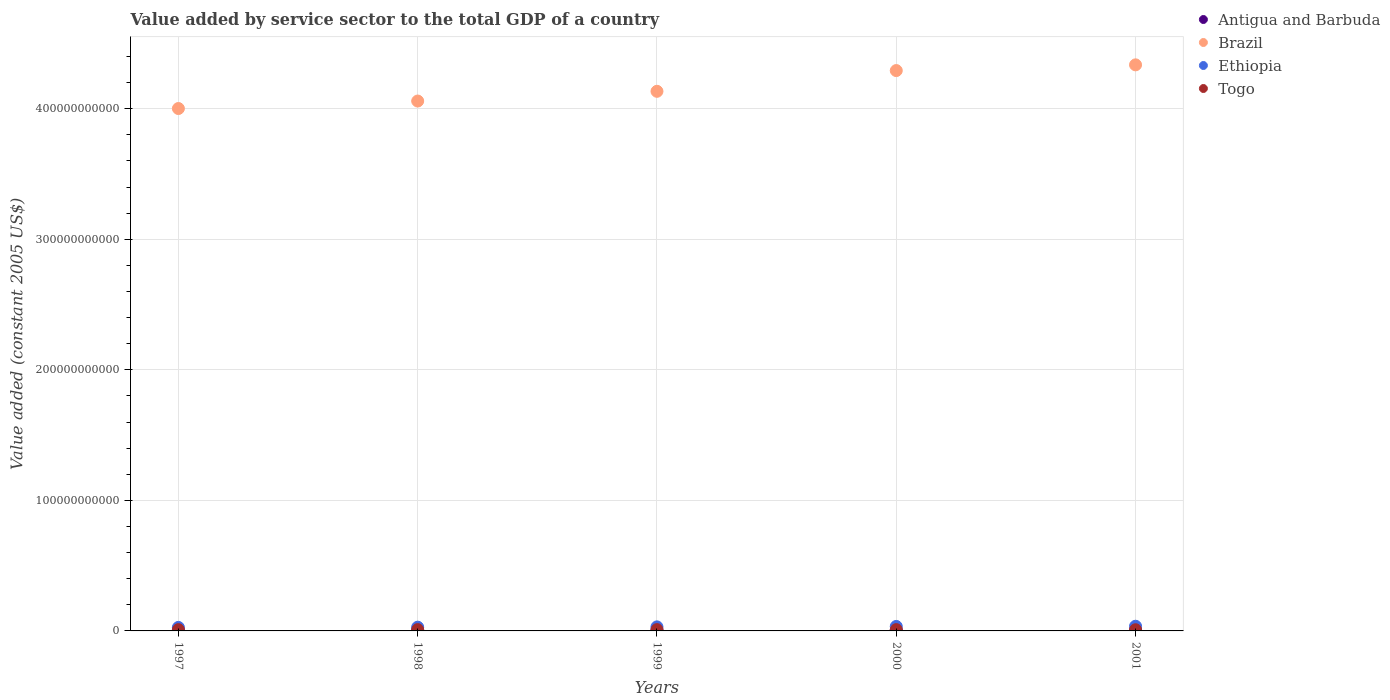Is the number of dotlines equal to the number of legend labels?
Give a very brief answer. Yes. What is the value added by service sector in Antigua and Barbuda in 1999?
Provide a short and direct response. 5.71e+08. Across all years, what is the maximum value added by service sector in Ethiopia?
Ensure brevity in your answer.  3.59e+09. Across all years, what is the minimum value added by service sector in Ethiopia?
Offer a terse response. 2.69e+09. In which year was the value added by service sector in Togo maximum?
Offer a terse response. 2000. In which year was the value added by service sector in Antigua and Barbuda minimum?
Ensure brevity in your answer.  1997. What is the total value added by service sector in Togo in the graph?
Your answer should be very brief. 4.85e+09. What is the difference between the value added by service sector in Togo in 1998 and that in 1999?
Your answer should be compact. 1.62e+06. What is the difference between the value added by service sector in Brazil in 1997 and the value added by service sector in Togo in 2000?
Make the answer very short. 3.99e+11. What is the average value added by service sector in Brazil per year?
Ensure brevity in your answer.  4.16e+11. In the year 1997, what is the difference between the value added by service sector in Ethiopia and value added by service sector in Brazil?
Offer a terse response. -3.97e+11. What is the ratio of the value added by service sector in Togo in 1998 to that in 1999?
Offer a terse response. 1. Is the difference between the value added by service sector in Ethiopia in 1997 and 1999 greater than the difference between the value added by service sector in Brazil in 1997 and 1999?
Ensure brevity in your answer.  Yes. What is the difference between the highest and the second highest value added by service sector in Ethiopia?
Give a very brief answer. 1.56e+08. What is the difference between the highest and the lowest value added by service sector in Brazil?
Ensure brevity in your answer.  3.35e+1. Is the sum of the value added by service sector in Togo in 1997 and 1999 greater than the maximum value added by service sector in Ethiopia across all years?
Keep it short and to the point. No. Is the value added by service sector in Antigua and Barbuda strictly less than the value added by service sector in Brazil over the years?
Give a very brief answer. Yes. How many dotlines are there?
Keep it short and to the point. 4. What is the difference between two consecutive major ticks on the Y-axis?
Give a very brief answer. 1.00e+11. Does the graph contain any zero values?
Offer a very short reply. No. Where does the legend appear in the graph?
Make the answer very short. Top right. How are the legend labels stacked?
Keep it short and to the point. Vertical. What is the title of the graph?
Offer a terse response. Value added by service sector to the total GDP of a country. Does "Mexico" appear as one of the legend labels in the graph?
Provide a short and direct response. No. What is the label or title of the Y-axis?
Provide a succinct answer. Value added (constant 2005 US$). What is the Value added (constant 2005 US$) of Antigua and Barbuda in 1997?
Give a very brief answer. 5.24e+08. What is the Value added (constant 2005 US$) in Brazil in 1997?
Give a very brief answer. 4.00e+11. What is the Value added (constant 2005 US$) in Ethiopia in 1997?
Offer a terse response. 2.69e+09. What is the Value added (constant 2005 US$) in Togo in 1997?
Your answer should be compact. 9.75e+08. What is the Value added (constant 2005 US$) of Antigua and Barbuda in 1998?
Ensure brevity in your answer.  5.47e+08. What is the Value added (constant 2005 US$) in Brazil in 1998?
Keep it short and to the point. 4.06e+11. What is the Value added (constant 2005 US$) of Ethiopia in 1998?
Keep it short and to the point. 2.86e+09. What is the Value added (constant 2005 US$) of Togo in 1998?
Ensure brevity in your answer.  9.86e+08. What is the Value added (constant 2005 US$) of Antigua and Barbuda in 1999?
Your response must be concise. 5.71e+08. What is the Value added (constant 2005 US$) of Brazil in 1999?
Your answer should be very brief. 4.13e+11. What is the Value added (constant 2005 US$) in Ethiopia in 1999?
Provide a succinct answer. 3.10e+09. What is the Value added (constant 2005 US$) of Togo in 1999?
Offer a very short reply. 9.85e+08. What is the Value added (constant 2005 US$) of Antigua and Barbuda in 2000?
Ensure brevity in your answer.  6.12e+08. What is the Value added (constant 2005 US$) in Brazil in 2000?
Offer a very short reply. 4.29e+11. What is the Value added (constant 2005 US$) of Ethiopia in 2000?
Make the answer very short. 3.43e+09. What is the Value added (constant 2005 US$) of Togo in 2000?
Ensure brevity in your answer.  9.91e+08. What is the Value added (constant 2005 US$) in Antigua and Barbuda in 2001?
Provide a short and direct response. 6.04e+08. What is the Value added (constant 2005 US$) in Brazil in 2001?
Make the answer very short. 4.34e+11. What is the Value added (constant 2005 US$) of Ethiopia in 2001?
Your response must be concise. 3.59e+09. What is the Value added (constant 2005 US$) in Togo in 2001?
Your answer should be compact. 9.10e+08. Across all years, what is the maximum Value added (constant 2005 US$) in Antigua and Barbuda?
Ensure brevity in your answer.  6.12e+08. Across all years, what is the maximum Value added (constant 2005 US$) in Brazil?
Your response must be concise. 4.34e+11. Across all years, what is the maximum Value added (constant 2005 US$) in Ethiopia?
Your answer should be compact. 3.59e+09. Across all years, what is the maximum Value added (constant 2005 US$) of Togo?
Your answer should be very brief. 9.91e+08. Across all years, what is the minimum Value added (constant 2005 US$) in Antigua and Barbuda?
Provide a short and direct response. 5.24e+08. Across all years, what is the minimum Value added (constant 2005 US$) in Brazil?
Offer a terse response. 4.00e+11. Across all years, what is the minimum Value added (constant 2005 US$) in Ethiopia?
Offer a very short reply. 2.69e+09. Across all years, what is the minimum Value added (constant 2005 US$) in Togo?
Your response must be concise. 9.10e+08. What is the total Value added (constant 2005 US$) in Antigua and Barbuda in the graph?
Give a very brief answer. 2.86e+09. What is the total Value added (constant 2005 US$) in Brazil in the graph?
Provide a short and direct response. 2.08e+12. What is the total Value added (constant 2005 US$) in Ethiopia in the graph?
Offer a terse response. 1.57e+1. What is the total Value added (constant 2005 US$) in Togo in the graph?
Provide a succinct answer. 4.85e+09. What is the difference between the Value added (constant 2005 US$) of Antigua and Barbuda in 1997 and that in 1998?
Your answer should be very brief. -2.31e+07. What is the difference between the Value added (constant 2005 US$) of Brazil in 1997 and that in 1998?
Offer a terse response. -5.73e+09. What is the difference between the Value added (constant 2005 US$) in Ethiopia in 1997 and that in 1998?
Make the answer very short. -1.74e+08. What is the difference between the Value added (constant 2005 US$) of Togo in 1997 and that in 1998?
Provide a short and direct response. -1.19e+07. What is the difference between the Value added (constant 2005 US$) of Antigua and Barbuda in 1997 and that in 1999?
Offer a terse response. -4.69e+07. What is the difference between the Value added (constant 2005 US$) of Brazil in 1997 and that in 1999?
Give a very brief answer. -1.32e+1. What is the difference between the Value added (constant 2005 US$) in Ethiopia in 1997 and that in 1999?
Your answer should be compact. -4.07e+08. What is the difference between the Value added (constant 2005 US$) in Togo in 1997 and that in 1999?
Provide a succinct answer. -1.03e+07. What is the difference between the Value added (constant 2005 US$) of Antigua and Barbuda in 1997 and that in 2000?
Keep it short and to the point. -8.82e+07. What is the difference between the Value added (constant 2005 US$) of Brazil in 1997 and that in 2000?
Provide a succinct answer. -2.91e+1. What is the difference between the Value added (constant 2005 US$) in Ethiopia in 1997 and that in 2000?
Offer a very short reply. -7.44e+08. What is the difference between the Value added (constant 2005 US$) in Togo in 1997 and that in 2000?
Give a very brief answer. -1.60e+07. What is the difference between the Value added (constant 2005 US$) in Antigua and Barbuda in 1997 and that in 2001?
Your answer should be compact. -8.02e+07. What is the difference between the Value added (constant 2005 US$) of Brazil in 1997 and that in 2001?
Offer a very short reply. -3.35e+1. What is the difference between the Value added (constant 2005 US$) of Ethiopia in 1997 and that in 2001?
Keep it short and to the point. -9.00e+08. What is the difference between the Value added (constant 2005 US$) of Togo in 1997 and that in 2001?
Your answer should be very brief. 6.45e+07. What is the difference between the Value added (constant 2005 US$) in Antigua and Barbuda in 1998 and that in 1999?
Offer a terse response. -2.38e+07. What is the difference between the Value added (constant 2005 US$) in Brazil in 1998 and that in 1999?
Your answer should be compact. -7.46e+09. What is the difference between the Value added (constant 2005 US$) of Ethiopia in 1998 and that in 1999?
Provide a short and direct response. -2.32e+08. What is the difference between the Value added (constant 2005 US$) of Togo in 1998 and that in 1999?
Your answer should be very brief. 1.62e+06. What is the difference between the Value added (constant 2005 US$) of Antigua and Barbuda in 1998 and that in 2000?
Your response must be concise. -6.51e+07. What is the difference between the Value added (constant 2005 US$) of Brazil in 1998 and that in 2000?
Provide a short and direct response. -2.33e+1. What is the difference between the Value added (constant 2005 US$) of Ethiopia in 1998 and that in 2000?
Your answer should be very brief. -5.69e+08. What is the difference between the Value added (constant 2005 US$) in Togo in 1998 and that in 2000?
Ensure brevity in your answer.  -4.05e+06. What is the difference between the Value added (constant 2005 US$) in Antigua and Barbuda in 1998 and that in 2001?
Offer a very short reply. -5.71e+07. What is the difference between the Value added (constant 2005 US$) of Brazil in 1998 and that in 2001?
Offer a very short reply. -2.77e+1. What is the difference between the Value added (constant 2005 US$) of Ethiopia in 1998 and that in 2001?
Your response must be concise. -7.25e+08. What is the difference between the Value added (constant 2005 US$) in Togo in 1998 and that in 2001?
Keep it short and to the point. 7.65e+07. What is the difference between the Value added (constant 2005 US$) in Antigua and Barbuda in 1999 and that in 2000?
Provide a succinct answer. -4.13e+07. What is the difference between the Value added (constant 2005 US$) in Brazil in 1999 and that in 2000?
Your response must be concise. -1.59e+1. What is the difference between the Value added (constant 2005 US$) in Ethiopia in 1999 and that in 2000?
Make the answer very short. -3.37e+08. What is the difference between the Value added (constant 2005 US$) of Togo in 1999 and that in 2000?
Give a very brief answer. -5.67e+06. What is the difference between the Value added (constant 2005 US$) in Antigua and Barbuda in 1999 and that in 2001?
Ensure brevity in your answer.  -3.32e+07. What is the difference between the Value added (constant 2005 US$) in Brazil in 1999 and that in 2001?
Give a very brief answer. -2.03e+1. What is the difference between the Value added (constant 2005 US$) in Ethiopia in 1999 and that in 2001?
Make the answer very short. -4.93e+08. What is the difference between the Value added (constant 2005 US$) of Togo in 1999 and that in 2001?
Make the answer very short. 7.49e+07. What is the difference between the Value added (constant 2005 US$) in Antigua and Barbuda in 2000 and that in 2001?
Ensure brevity in your answer.  8.03e+06. What is the difference between the Value added (constant 2005 US$) in Brazil in 2000 and that in 2001?
Give a very brief answer. -4.39e+09. What is the difference between the Value added (constant 2005 US$) in Ethiopia in 2000 and that in 2001?
Provide a succinct answer. -1.56e+08. What is the difference between the Value added (constant 2005 US$) in Togo in 2000 and that in 2001?
Offer a very short reply. 8.05e+07. What is the difference between the Value added (constant 2005 US$) of Antigua and Barbuda in 1997 and the Value added (constant 2005 US$) of Brazil in 1998?
Your response must be concise. -4.05e+11. What is the difference between the Value added (constant 2005 US$) in Antigua and Barbuda in 1997 and the Value added (constant 2005 US$) in Ethiopia in 1998?
Provide a short and direct response. -2.34e+09. What is the difference between the Value added (constant 2005 US$) in Antigua and Barbuda in 1997 and the Value added (constant 2005 US$) in Togo in 1998?
Your answer should be compact. -4.63e+08. What is the difference between the Value added (constant 2005 US$) in Brazil in 1997 and the Value added (constant 2005 US$) in Ethiopia in 1998?
Keep it short and to the point. 3.97e+11. What is the difference between the Value added (constant 2005 US$) of Brazil in 1997 and the Value added (constant 2005 US$) of Togo in 1998?
Provide a short and direct response. 3.99e+11. What is the difference between the Value added (constant 2005 US$) in Ethiopia in 1997 and the Value added (constant 2005 US$) in Togo in 1998?
Your response must be concise. 1.70e+09. What is the difference between the Value added (constant 2005 US$) in Antigua and Barbuda in 1997 and the Value added (constant 2005 US$) in Brazil in 1999?
Your response must be concise. -4.13e+11. What is the difference between the Value added (constant 2005 US$) in Antigua and Barbuda in 1997 and the Value added (constant 2005 US$) in Ethiopia in 1999?
Keep it short and to the point. -2.57e+09. What is the difference between the Value added (constant 2005 US$) in Antigua and Barbuda in 1997 and the Value added (constant 2005 US$) in Togo in 1999?
Provide a succinct answer. -4.61e+08. What is the difference between the Value added (constant 2005 US$) of Brazil in 1997 and the Value added (constant 2005 US$) of Ethiopia in 1999?
Your response must be concise. 3.97e+11. What is the difference between the Value added (constant 2005 US$) of Brazil in 1997 and the Value added (constant 2005 US$) of Togo in 1999?
Provide a succinct answer. 3.99e+11. What is the difference between the Value added (constant 2005 US$) of Ethiopia in 1997 and the Value added (constant 2005 US$) of Togo in 1999?
Provide a short and direct response. 1.71e+09. What is the difference between the Value added (constant 2005 US$) of Antigua and Barbuda in 1997 and the Value added (constant 2005 US$) of Brazil in 2000?
Make the answer very short. -4.29e+11. What is the difference between the Value added (constant 2005 US$) in Antigua and Barbuda in 1997 and the Value added (constant 2005 US$) in Ethiopia in 2000?
Provide a short and direct response. -2.91e+09. What is the difference between the Value added (constant 2005 US$) in Antigua and Barbuda in 1997 and the Value added (constant 2005 US$) in Togo in 2000?
Offer a terse response. -4.67e+08. What is the difference between the Value added (constant 2005 US$) of Brazil in 1997 and the Value added (constant 2005 US$) of Ethiopia in 2000?
Make the answer very short. 3.97e+11. What is the difference between the Value added (constant 2005 US$) in Brazil in 1997 and the Value added (constant 2005 US$) in Togo in 2000?
Ensure brevity in your answer.  3.99e+11. What is the difference between the Value added (constant 2005 US$) in Ethiopia in 1997 and the Value added (constant 2005 US$) in Togo in 2000?
Make the answer very short. 1.70e+09. What is the difference between the Value added (constant 2005 US$) of Antigua and Barbuda in 1997 and the Value added (constant 2005 US$) of Brazil in 2001?
Make the answer very short. -4.33e+11. What is the difference between the Value added (constant 2005 US$) in Antigua and Barbuda in 1997 and the Value added (constant 2005 US$) in Ethiopia in 2001?
Make the answer very short. -3.07e+09. What is the difference between the Value added (constant 2005 US$) of Antigua and Barbuda in 1997 and the Value added (constant 2005 US$) of Togo in 2001?
Your answer should be compact. -3.86e+08. What is the difference between the Value added (constant 2005 US$) of Brazil in 1997 and the Value added (constant 2005 US$) of Ethiopia in 2001?
Make the answer very short. 3.97e+11. What is the difference between the Value added (constant 2005 US$) of Brazil in 1997 and the Value added (constant 2005 US$) of Togo in 2001?
Your answer should be very brief. 3.99e+11. What is the difference between the Value added (constant 2005 US$) of Ethiopia in 1997 and the Value added (constant 2005 US$) of Togo in 2001?
Make the answer very short. 1.78e+09. What is the difference between the Value added (constant 2005 US$) of Antigua and Barbuda in 1998 and the Value added (constant 2005 US$) of Brazil in 1999?
Make the answer very short. -4.13e+11. What is the difference between the Value added (constant 2005 US$) in Antigua and Barbuda in 1998 and the Value added (constant 2005 US$) in Ethiopia in 1999?
Provide a succinct answer. -2.55e+09. What is the difference between the Value added (constant 2005 US$) of Antigua and Barbuda in 1998 and the Value added (constant 2005 US$) of Togo in 1999?
Your answer should be compact. -4.38e+08. What is the difference between the Value added (constant 2005 US$) of Brazil in 1998 and the Value added (constant 2005 US$) of Ethiopia in 1999?
Give a very brief answer. 4.03e+11. What is the difference between the Value added (constant 2005 US$) in Brazil in 1998 and the Value added (constant 2005 US$) in Togo in 1999?
Give a very brief answer. 4.05e+11. What is the difference between the Value added (constant 2005 US$) of Ethiopia in 1998 and the Value added (constant 2005 US$) of Togo in 1999?
Provide a short and direct response. 1.88e+09. What is the difference between the Value added (constant 2005 US$) of Antigua and Barbuda in 1998 and the Value added (constant 2005 US$) of Brazil in 2000?
Give a very brief answer. -4.29e+11. What is the difference between the Value added (constant 2005 US$) in Antigua and Barbuda in 1998 and the Value added (constant 2005 US$) in Ethiopia in 2000?
Provide a short and direct response. -2.89e+09. What is the difference between the Value added (constant 2005 US$) in Antigua and Barbuda in 1998 and the Value added (constant 2005 US$) in Togo in 2000?
Provide a short and direct response. -4.44e+08. What is the difference between the Value added (constant 2005 US$) of Brazil in 1998 and the Value added (constant 2005 US$) of Ethiopia in 2000?
Provide a succinct answer. 4.02e+11. What is the difference between the Value added (constant 2005 US$) of Brazil in 1998 and the Value added (constant 2005 US$) of Togo in 2000?
Keep it short and to the point. 4.05e+11. What is the difference between the Value added (constant 2005 US$) of Ethiopia in 1998 and the Value added (constant 2005 US$) of Togo in 2000?
Provide a succinct answer. 1.87e+09. What is the difference between the Value added (constant 2005 US$) in Antigua and Barbuda in 1998 and the Value added (constant 2005 US$) in Brazil in 2001?
Provide a short and direct response. -4.33e+11. What is the difference between the Value added (constant 2005 US$) of Antigua and Barbuda in 1998 and the Value added (constant 2005 US$) of Ethiopia in 2001?
Keep it short and to the point. -3.04e+09. What is the difference between the Value added (constant 2005 US$) in Antigua and Barbuda in 1998 and the Value added (constant 2005 US$) in Togo in 2001?
Offer a very short reply. -3.63e+08. What is the difference between the Value added (constant 2005 US$) of Brazil in 1998 and the Value added (constant 2005 US$) of Ethiopia in 2001?
Ensure brevity in your answer.  4.02e+11. What is the difference between the Value added (constant 2005 US$) in Brazil in 1998 and the Value added (constant 2005 US$) in Togo in 2001?
Provide a short and direct response. 4.05e+11. What is the difference between the Value added (constant 2005 US$) in Ethiopia in 1998 and the Value added (constant 2005 US$) in Togo in 2001?
Your response must be concise. 1.95e+09. What is the difference between the Value added (constant 2005 US$) in Antigua and Barbuda in 1999 and the Value added (constant 2005 US$) in Brazil in 2000?
Give a very brief answer. -4.29e+11. What is the difference between the Value added (constant 2005 US$) in Antigua and Barbuda in 1999 and the Value added (constant 2005 US$) in Ethiopia in 2000?
Offer a very short reply. -2.86e+09. What is the difference between the Value added (constant 2005 US$) of Antigua and Barbuda in 1999 and the Value added (constant 2005 US$) of Togo in 2000?
Your answer should be very brief. -4.20e+08. What is the difference between the Value added (constant 2005 US$) in Brazil in 1999 and the Value added (constant 2005 US$) in Ethiopia in 2000?
Keep it short and to the point. 4.10e+11. What is the difference between the Value added (constant 2005 US$) of Brazil in 1999 and the Value added (constant 2005 US$) of Togo in 2000?
Offer a terse response. 4.12e+11. What is the difference between the Value added (constant 2005 US$) of Ethiopia in 1999 and the Value added (constant 2005 US$) of Togo in 2000?
Give a very brief answer. 2.11e+09. What is the difference between the Value added (constant 2005 US$) in Antigua and Barbuda in 1999 and the Value added (constant 2005 US$) in Brazil in 2001?
Ensure brevity in your answer.  -4.33e+11. What is the difference between the Value added (constant 2005 US$) of Antigua and Barbuda in 1999 and the Value added (constant 2005 US$) of Ethiopia in 2001?
Your answer should be compact. -3.02e+09. What is the difference between the Value added (constant 2005 US$) in Antigua and Barbuda in 1999 and the Value added (constant 2005 US$) in Togo in 2001?
Your response must be concise. -3.39e+08. What is the difference between the Value added (constant 2005 US$) in Brazil in 1999 and the Value added (constant 2005 US$) in Ethiopia in 2001?
Ensure brevity in your answer.  4.10e+11. What is the difference between the Value added (constant 2005 US$) in Brazil in 1999 and the Value added (constant 2005 US$) in Togo in 2001?
Provide a short and direct response. 4.12e+11. What is the difference between the Value added (constant 2005 US$) of Ethiopia in 1999 and the Value added (constant 2005 US$) of Togo in 2001?
Offer a very short reply. 2.19e+09. What is the difference between the Value added (constant 2005 US$) of Antigua and Barbuda in 2000 and the Value added (constant 2005 US$) of Brazil in 2001?
Your response must be concise. -4.33e+11. What is the difference between the Value added (constant 2005 US$) in Antigua and Barbuda in 2000 and the Value added (constant 2005 US$) in Ethiopia in 2001?
Make the answer very short. -2.98e+09. What is the difference between the Value added (constant 2005 US$) of Antigua and Barbuda in 2000 and the Value added (constant 2005 US$) of Togo in 2001?
Give a very brief answer. -2.98e+08. What is the difference between the Value added (constant 2005 US$) in Brazil in 2000 and the Value added (constant 2005 US$) in Ethiopia in 2001?
Your answer should be compact. 4.26e+11. What is the difference between the Value added (constant 2005 US$) in Brazil in 2000 and the Value added (constant 2005 US$) in Togo in 2001?
Ensure brevity in your answer.  4.28e+11. What is the difference between the Value added (constant 2005 US$) in Ethiopia in 2000 and the Value added (constant 2005 US$) in Togo in 2001?
Provide a short and direct response. 2.52e+09. What is the average Value added (constant 2005 US$) of Antigua and Barbuda per year?
Your response must be concise. 5.71e+08. What is the average Value added (constant 2005 US$) of Brazil per year?
Offer a terse response. 4.16e+11. What is the average Value added (constant 2005 US$) of Ethiopia per year?
Provide a short and direct response. 3.13e+09. What is the average Value added (constant 2005 US$) of Togo per year?
Your response must be concise. 9.69e+08. In the year 1997, what is the difference between the Value added (constant 2005 US$) in Antigua and Barbuda and Value added (constant 2005 US$) in Brazil?
Provide a succinct answer. -4.00e+11. In the year 1997, what is the difference between the Value added (constant 2005 US$) of Antigua and Barbuda and Value added (constant 2005 US$) of Ethiopia?
Ensure brevity in your answer.  -2.17e+09. In the year 1997, what is the difference between the Value added (constant 2005 US$) in Antigua and Barbuda and Value added (constant 2005 US$) in Togo?
Offer a very short reply. -4.51e+08. In the year 1997, what is the difference between the Value added (constant 2005 US$) in Brazil and Value added (constant 2005 US$) in Ethiopia?
Offer a terse response. 3.97e+11. In the year 1997, what is the difference between the Value added (constant 2005 US$) of Brazil and Value added (constant 2005 US$) of Togo?
Your response must be concise. 3.99e+11. In the year 1997, what is the difference between the Value added (constant 2005 US$) of Ethiopia and Value added (constant 2005 US$) of Togo?
Keep it short and to the point. 1.72e+09. In the year 1998, what is the difference between the Value added (constant 2005 US$) in Antigua and Barbuda and Value added (constant 2005 US$) in Brazil?
Give a very brief answer. -4.05e+11. In the year 1998, what is the difference between the Value added (constant 2005 US$) in Antigua and Barbuda and Value added (constant 2005 US$) in Ethiopia?
Provide a short and direct response. -2.32e+09. In the year 1998, what is the difference between the Value added (constant 2005 US$) of Antigua and Barbuda and Value added (constant 2005 US$) of Togo?
Make the answer very short. -4.40e+08. In the year 1998, what is the difference between the Value added (constant 2005 US$) of Brazil and Value added (constant 2005 US$) of Ethiopia?
Offer a very short reply. 4.03e+11. In the year 1998, what is the difference between the Value added (constant 2005 US$) in Brazil and Value added (constant 2005 US$) in Togo?
Provide a short and direct response. 4.05e+11. In the year 1998, what is the difference between the Value added (constant 2005 US$) of Ethiopia and Value added (constant 2005 US$) of Togo?
Provide a short and direct response. 1.88e+09. In the year 1999, what is the difference between the Value added (constant 2005 US$) in Antigua and Barbuda and Value added (constant 2005 US$) in Brazil?
Make the answer very short. -4.13e+11. In the year 1999, what is the difference between the Value added (constant 2005 US$) in Antigua and Barbuda and Value added (constant 2005 US$) in Ethiopia?
Give a very brief answer. -2.53e+09. In the year 1999, what is the difference between the Value added (constant 2005 US$) of Antigua and Barbuda and Value added (constant 2005 US$) of Togo?
Your answer should be compact. -4.14e+08. In the year 1999, what is the difference between the Value added (constant 2005 US$) in Brazil and Value added (constant 2005 US$) in Ethiopia?
Your answer should be very brief. 4.10e+11. In the year 1999, what is the difference between the Value added (constant 2005 US$) of Brazil and Value added (constant 2005 US$) of Togo?
Offer a very short reply. 4.12e+11. In the year 1999, what is the difference between the Value added (constant 2005 US$) of Ethiopia and Value added (constant 2005 US$) of Togo?
Make the answer very short. 2.11e+09. In the year 2000, what is the difference between the Value added (constant 2005 US$) in Antigua and Barbuda and Value added (constant 2005 US$) in Brazil?
Ensure brevity in your answer.  -4.29e+11. In the year 2000, what is the difference between the Value added (constant 2005 US$) in Antigua and Barbuda and Value added (constant 2005 US$) in Ethiopia?
Your answer should be compact. -2.82e+09. In the year 2000, what is the difference between the Value added (constant 2005 US$) in Antigua and Barbuda and Value added (constant 2005 US$) in Togo?
Your response must be concise. -3.79e+08. In the year 2000, what is the difference between the Value added (constant 2005 US$) of Brazil and Value added (constant 2005 US$) of Ethiopia?
Offer a very short reply. 4.26e+11. In the year 2000, what is the difference between the Value added (constant 2005 US$) in Brazil and Value added (constant 2005 US$) in Togo?
Keep it short and to the point. 4.28e+11. In the year 2000, what is the difference between the Value added (constant 2005 US$) of Ethiopia and Value added (constant 2005 US$) of Togo?
Your answer should be compact. 2.44e+09. In the year 2001, what is the difference between the Value added (constant 2005 US$) in Antigua and Barbuda and Value added (constant 2005 US$) in Brazil?
Offer a very short reply. -4.33e+11. In the year 2001, what is the difference between the Value added (constant 2005 US$) of Antigua and Barbuda and Value added (constant 2005 US$) of Ethiopia?
Offer a terse response. -2.99e+09. In the year 2001, what is the difference between the Value added (constant 2005 US$) of Antigua and Barbuda and Value added (constant 2005 US$) of Togo?
Keep it short and to the point. -3.06e+08. In the year 2001, what is the difference between the Value added (constant 2005 US$) in Brazil and Value added (constant 2005 US$) in Ethiopia?
Ensure brevity in your answer.  4.30e+11. In the year 2001, what is the difference between the Value added (constant 2005 US$) of Brazil and Value added (constant 2005 US$) of Togo?
Give a very brief answer. 4.33e+11. In the year 2001, what is the difference between the Value added (constant 2005 US$) in Ethiopia and Value added (constant 2005 US$) in Togo?
Provide a short and direct response. 2.68e+09. What is the ratio of the Value added (constant 2005 US$) in Antigua and Barbuda in 1997 to that in 1998?
Provide a short and direct response. 0.96. What is the ratio of the Value added (constant 2005 US$) of Brazil in 1997 to that in 1998?
Keep it short and to the point. 0.99. What is the ratio of the Value added (constant 2005 US$) in Ethiopia in 1997 to that in 1998?
Provide a succinct answer. 0.94. What is the ratio of the Value added (constant 2005 US$) in Togo in 1997 to that in 1998?
Make the answer very short. 0.99. What is the ratio of the Value added (constant 2005 US$) in Antigua and Barbuda in 1997 to that in 1999?
Provide a succinct answer. 0.92. What is the ratio of the Value added (constant 2005 US$) in Brazil in 1997 to that in 1999?
Your answer should be very brief. 0.97. What is the ratio of the Value added (constant 2005 US$) in Ethiopia in 1997 to that in 1999?
Your answer should be compact. 0.87. What is the ratio of the Value added (constant 2005 US$) of Antigua and Barbuda in 1997 to that in 2000?
Provide a short and direct response. 0.86. What is the ratio of the Value added (constant 2005 US$) of Brazil in 1997 to that in 2000?
Provide a short and direct response. 0.93. What is the ratio of the Value added (constant 2005 US$) of Ethiopia in 1997 to that in 2000?
Provide a succinct answer. 0.78. What is the ratio of the Value added (constant 2005 US$) of Togo in 1997 to that in 2000?
Keep it short and to the point. 0.98. What is the ratio of the Value added (constant 2005 US$) of Antigua and Barbuda in 1997 to that in 2001?
Your response must be concise. 0.87. What is the ratio of the Value added (constant 2005 US$) of Brazil in 1997 to that in 2001?
Ensure brevity in your answer.  0.92. What is the ratio of the Value added (constant 2005 US$) in Ethiopia in 1997 to that in 2001?
Provide a short and direct response. 0.75. What is the ratio of the Value added (constant 2005 US$) in Togo in 1997 to that in 2001?
Give a very brief answer. 1.07. What is the ratio of the Value added (constant 2005 US$) of Antigua and Barbuda in 1998 to that in 1999?
Provide a succinct answer. 0.96. What is the ratio of the Value added (constant 2005 US$) in Ethiopia in 1998 to that in 1999?
Give a very brief answer. 0.93. What is the ratio of the Value added (constant 2005 US$) in Togo in 1998 to that in 1999?
Keep it short and to the point. 1. What is the ratio of the Value added (constant 2005 US$) of Antigua and Barbuda in 1998 to that in 2000?
Make the answer very short. 0.89. What is the ratio of the Value added (constant 2005 US$) of Brazil in 1998 to that in 2000?
Ensure brevity in your answer.  0.95. What is the ratio of the Value added (constant 2005 US$) of Ethiopia in 1998 to that in 2000?
Provide a short and direct response. 0.83. What is the ratio of the Value added (constant 2005 US$) of Togo in 1998 to that in 2000?
Your answer should be very brief. 1. What is the ratio of the Value added (constant 2005 US$) of Antigua and Barbuda in 1998 to that in 2001?
Ensure brevity in your answer.  0.91. What is the ratio of the Value added (constant 2005 US$) in Brazil in 1998 to that in 2001?
Your answer should be very brief. 0.94. What is the ratio of the Value added (constant 2005 US$) of Ethiopia in 1998 to that in 2001?
Provide a succinct answer. 0.8. What is the ratio of the Value added (constant 2005 US$) of Togo in 1998 to that in 2001?
Your answer should be compact. 1.08. What is the ratio of the Value added (constant 2005 US$) in Antigua and Barbuda in 1999 to that in 2000?
Offer a terse response. 0.93. What is the ratio of the Value added (constant 2005 US$) of Ethiopia in 1999 to that in 2000?
Provide a short and direct response. 0.9. What is the ratio of the Value added (constant 2005 US$) of Antigua and Barbuda in 1999 to that in 2001?
Provide a short and direct response. 0.94. What is the ratio of the Value added (constant 2005 US$) in Brazil in 1999 to that in 2001?
Provide a succinct answer. 0.95. What is the ratio of the Value added (constant 2005 US$) in Ethiopia in 1999 to that in 2001?
Provide a succinct answer. 0.86. What is the ratio of the Value added (constant 2005 US$) in Togo in 1999 to that in 2001?
Offer a terse response. 1.08. What is the ratio of the Value added (constant 2005 US$) in Antigua and Barbuda in 2000 to that in 2001?
Make the answer very short. 1.01. What is the ratio of the Value added (constant 2005 US$) of Brazil in 2000 to that in 2001?
Your answer should be compact. 0.99. What is the ratio of the Value added (constant 2005 US$) in Ethiopia in 2000 to that in 2001?
Provide a succinct answer. 0.96. What is the ratio of the Value added (constant 2005 US$) of Togo in 2000 to that in 2001?
Offer a very short reply. 1.09. What is the difference between the highest and the second highest Value added (constant 2005 US$) of Antigua and Barbuda?
Your answer should be compact. 8.03e+06. What is the difference between the highest and the second highest Value added (constant 2005 US$) of Brazil?
Your response must be concise. 4.39e+09. What is the difference between the highest and the second highest Value added (constant 2005 US$) in Ethiopia?
Make the answer very short. 1.56e+08. What is the difference between the highest and the second highest Value added (constant 2005 US$) in Togo?
Give a very brief answer. 4.05e+06. What is the difference between the highest and the lowest Value added (constant 2005 US$) of Antigua and Barbuda?
Your response must be concise. 8.82e+07. What is the difference between the highest and the lowest Value added (constant 2005 US$) in Brazil?
Your answer should be very brief. 3.35e+1. What is the difference between the highest and the lowest Value added (constant 2005 US$) of Ethiopia?
Your response must be concise. 9.00e+08. What is the difference between the highest and the lowest Value added (constant 2005 US$) of Togo?
Give a very brief answer. 8.05e+07. 